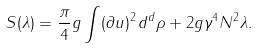Convert formula to latex. <formula><loc_0><loc_0><loc_500><loc_500>S ( \lambda ) = \frac { \pi } { 4 } g \int ( \partial u ) ^ { 2 } \, d ^ { d } \rho + 2 g \gamma ^ { 4 } N ^ { 2 } \lambda .</formula> 